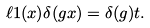Convert formula to latex. <formula><loc_0><loc_0><loc_500><loc_500>\ell 1 ( x ) \delta ( g x ) = \delta ( g ) t .</formula> 